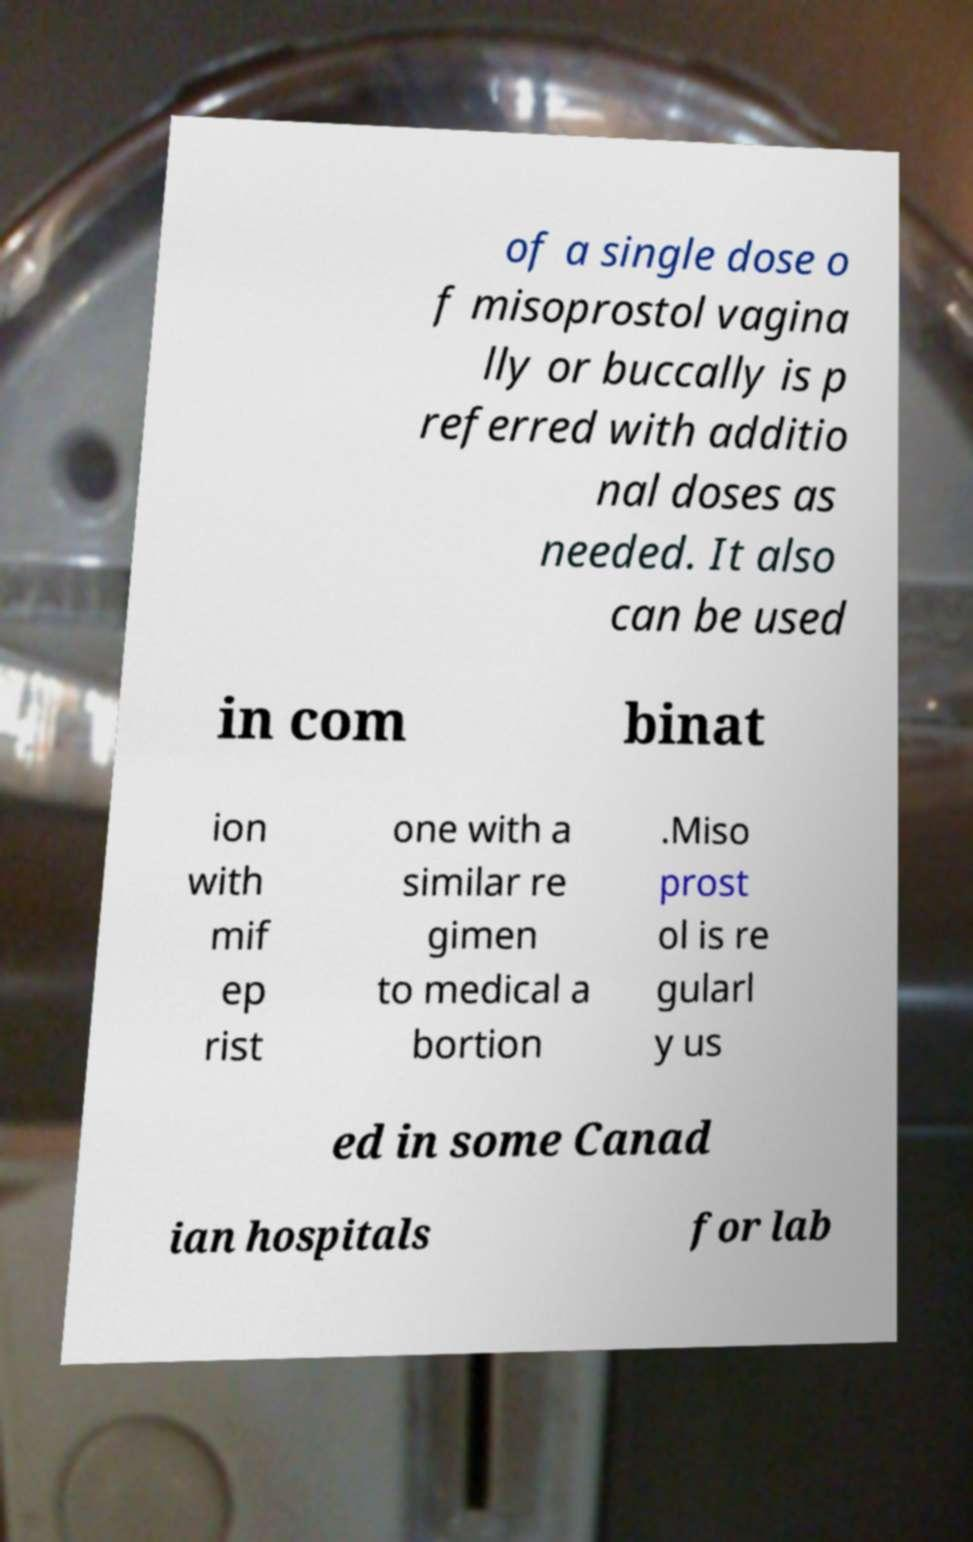There's text embedded in this image that I need extracted. Can you transcribe it verbatim? of a single dose o f misoprostol vagina lly or buccally is p referred with additio nal doses as needed. It also can be used in com binat ion with mif ep rist one with a similar re gimen to medical a bortion .Miso prost ol is re gularl y us ed in some Canad ian hospitals for lab 